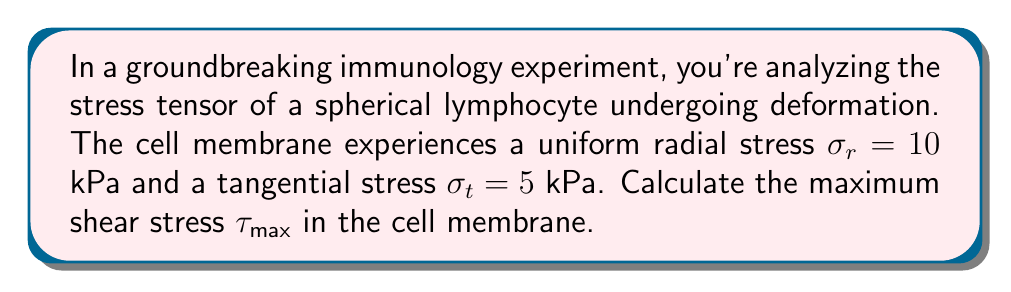Help me with this question. Let's approach this step-by-step:

1) In a spherical coordinate system, the stress tensor for a spherically symmetric stress state is given by:

   $$\sigma = \begin{pmatrix}
   \sigma_r & 0 & 0 \\
   0 & \sigma_t & 0 \\
   0 & 0 & \sigma_t
   \end{pmatrix}$$

2) The maximum shear stress $\tau_{max}$ is related to the principal stresses by:

   $$\tau_{max} = \frac{1}{2}(\sigma_{max} - \sigma_{min})$$

   Where $\sigma_{max}$ and $\sigma_{min}$ are the maximum and minimum principal stresses respectively.

3) In this case, we have:
   $\sigma_r = 10$ kPa
   $\sigma_t = 5$ kPa

4) To determine which is $\sigma_{max}$ and which is $\sigma_{min}$:
   $\sigma_r > \sigma_t$, so $\sigma_{max} = \sigma_r$ and $\sigma_{min} = \sigma_t$

5) Substituting into the formula:

   $$\tau_{max} = \frac{1}{2}(10 - 5) = \frac{1}{2}(5) = 2.5 \text{ kPa}$$

Thus, the maximum shear stress in the cell membrane is 2.5 kPa.
Answer: $2.5$ kPa 